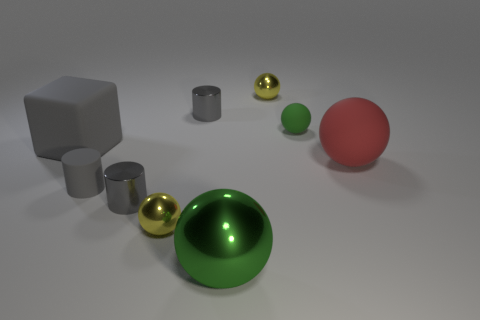Subtract all small matte balls. How many balls are left? 4 Subtract all green spheres. How many spheres are left? 3 Subtract 1 cylinders. How many cylinders are left? 2 Add 1 small green things. How many objects exist? 10 Subtract all blue spheres. Subtract all red cylinders. How many spheres are left? 5 Subtract all balls. How many objects are left? 4 Subtract all yellow spheres. Subtract all large red matte balls. How many objects are left? 6 Add 6 red matte spheres. How many red matte spheres are left? 7 Add 4 gray objects. How many gray objects exist? 8 Subtract 0 brown cubes. How many objects are left? 9 